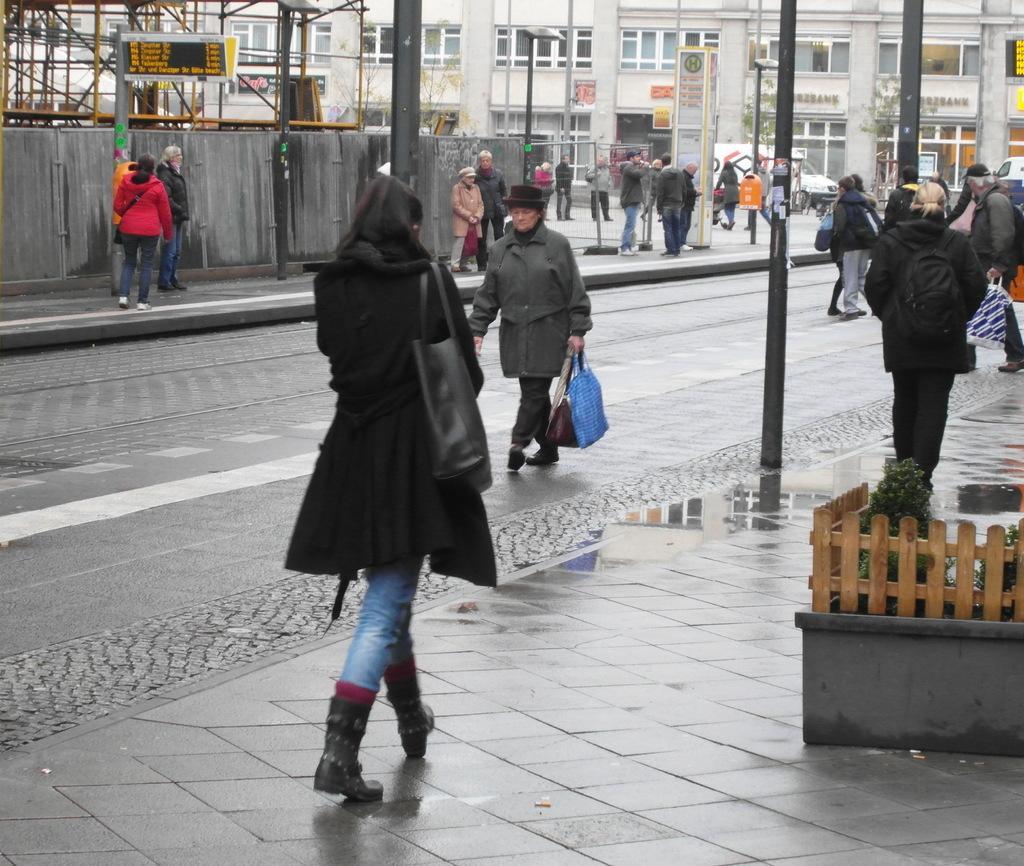Can you describe this image briefly? In this image we can see these people walking on the sidewalk. Here we can see the wooden fence, plants, poles, boards and the buildings in the background. 